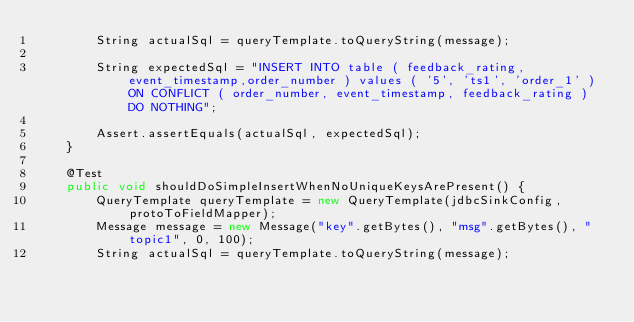Convert code to text. <code><loc_0><loc_0><loc_500><loc_500><_Java_>        String actualSql = queryTemplate.toQueryString(message);

        String expectedSql = "INSERT INTO table ( feedback_rating,event_timestamp,order_number ) values ( '5', 'ts1', 'order_1' ) ON CONFLICT ( order_number, event_timestamp, feedback_rating ) DO NOTHING";

        Assert.assertEquals(actualSql, expectedSql);
    }

    @Test
    public void shouldDoSimpleInsertWhenNoUniqueKeysArePresent() {
        QueryTemplate queryTemplate = new QueryTemplate(jdbcSinkConfig, protoToFieldMapper);
        Message message = new Message("key".getBytes(), "msg".getBytes(), "topic1", 0, 100);
        String actualSql = queryTemplate.toQueryString(message);
</code> 